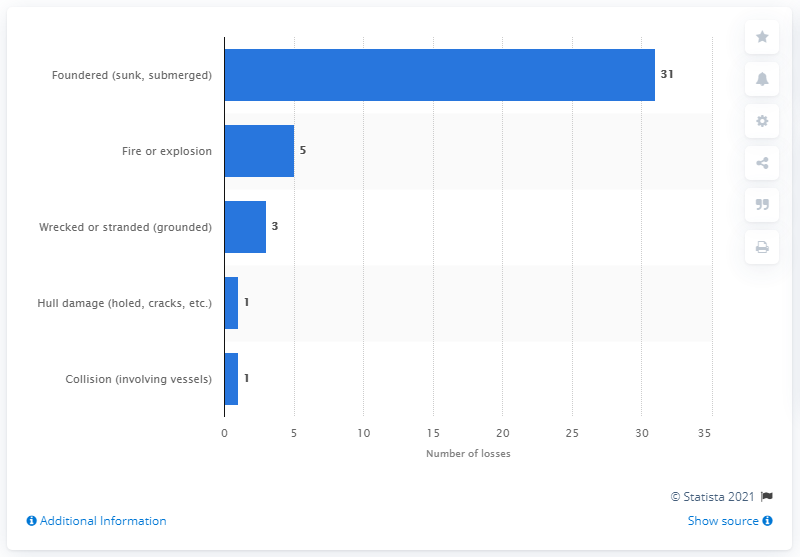Mention a couple of crucial points in this snapshot. In 2019, 31 of the 41 ship losses were foundered ships. 